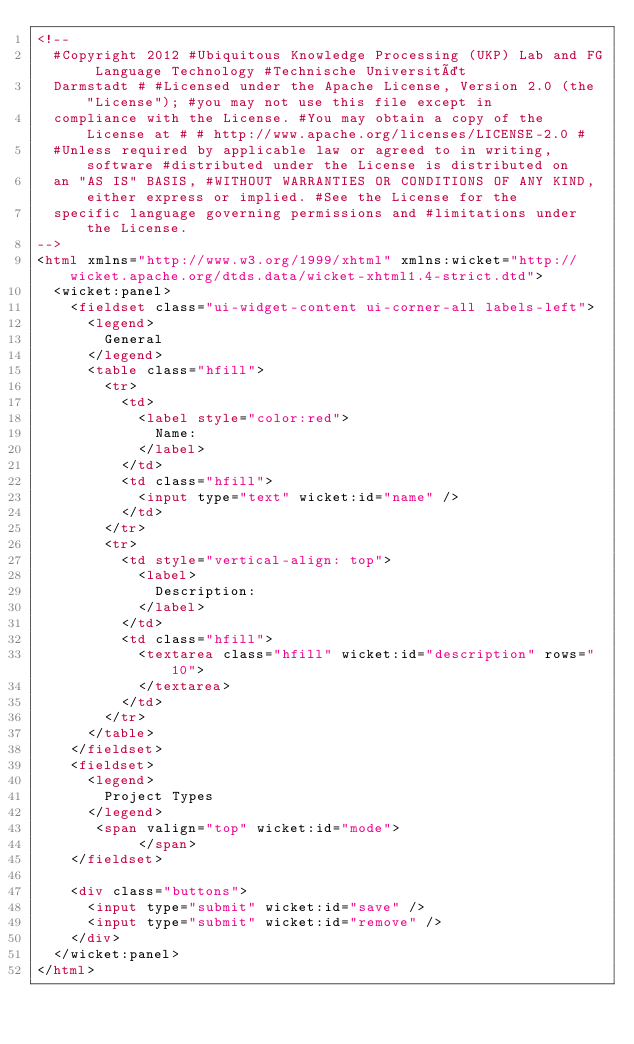<code> <loc_0><loc_0><loc_500><loc_500><_HTML_><!--
  #Copyright 2012 #Ubiquitous Knowledge Processing (UKP) Lab and FG Language Technology #Technische Universität
  Darmstadt # #Licensed under the Apache License, Version 2.0 (the "License"); #you may not use this file except in
  compliance with the License. #You may obtain a copy of the License at # # http://www.apache.org/licenses/LICENSE-2.0 #
  #Unless required by applicable law or agreed to in writing, software #distributed under the License is distributed on
  an "AS IS" BASIS, #WITHOUT WARRANTIES OR CONDITIONS OF ANY KIND, either express or implied. #See the License for the
  specific language governing permissions and #limitations under the License.
-->
<html xmlns="http://www.w3.org/1999/xhtml" xmlns:wicket="http://wicket.apache.org/dtds.data/wicket-xhtml1.4-strict.dtd">
  <wicket:panel>
    <fieldset class="ui-widget-content ui-corner-all labels-left">
      <legend>
        General
      </legend>
      <table class="hfill">
        <tr>
          <td>
            <label style="color:red">
              Name:
            </label>
          </td>
          <td class="hfill">
            <input type="text" wicket:id="name" />
          </td>
        </tr>
        <tr>
          <td style="vertical-align: top">
            <label>
              Description:
            </label>
          </td>
          <td class="hfill">
            <textarea class="hfill" wicket:id="description" rows="10">
            </textarea>
          </td>
        </tr>
      </table>
    </fieldset>
    <fieldset>
      <legend>
        Project Types
      </legend>
       <span valign="top" wicket:id="mode">
            </span>
    </fieldset>

    <div class="buttons">
      <input type="submit" wicket:id="save" />
      <input type="submit" wicket:id="remove" />
    </div>
  </wicket:panel>
</html>
</code> 